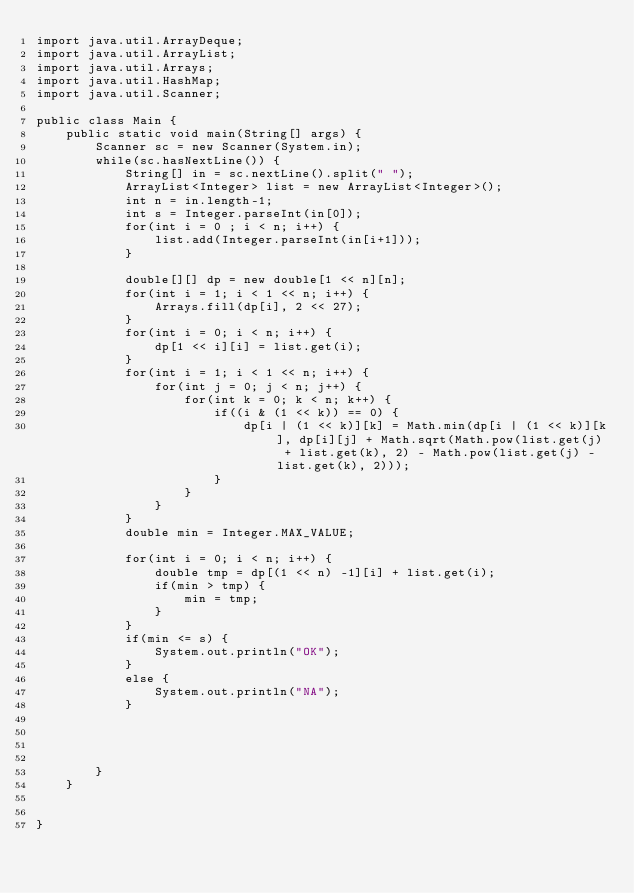Convert code to text. <code><loc_0><loc_0><loc_500><loc_500><_Java_>import java.util.ArrayDeque;
import java.util.ArrayList;
import java.util.Arrays;
import java.util.HashMap;
import java.util.Scanner;

public class Main {
	public static void main(String[] args) {
		Scanner sc = new Scanner(System.in);
		while(sc.hasNextLine()) {
			String[] in = sc.nextLine().split(" ");
			ArrayList<Integer> list = new ArrayList<Integer>();
			int n = in.length-1;
			int s = Integer.parseInt(in[0]);
			for(int i = 0 ; i < n; i++) {
				list.add(Integer.parseInt(in[i+1]));
			}
			
			double[][] dp = new double[1 << n][n];
			for(int i = 1; i < 1 << n; i++) {
				Arrays.fill(dp[i], 2 << 27);
			}
			for(int i = 0; i < n; i++) {
				dp[1 << i][i] = list.get(i);
			}
			for(int i = 1; i < 1 << n; i++) {
				for(int j = 0; j < n; j++) {
					for(int k = 0; k < n; k++) {
						if((i & (1 << k)) == 0) {
							dp[i | (1 << k)][k] = Math.min(dp[i | (1 << k)][k], dp[i][j] + Math.sqrt(Math.pow(list.get(j) + list.get(k), 2) - Math.pow(list.get(j) - list.get(k), 2)));
						}
					}
				}
			}
			double min = Integer.MAX_VALUE;
			
			for(int i = 0; i < n; i++) {
				double tmp = dp[(1 << n) -1][i] + list.get(i);
				if(min > tmp) {
					min = tmp;
				}
			}
			if(min <= s) {
				System.out.println("OK");
			}
			else {
				System.out.println("NA");
			}
			
			
			
			
		}
	}
	

}</code> 